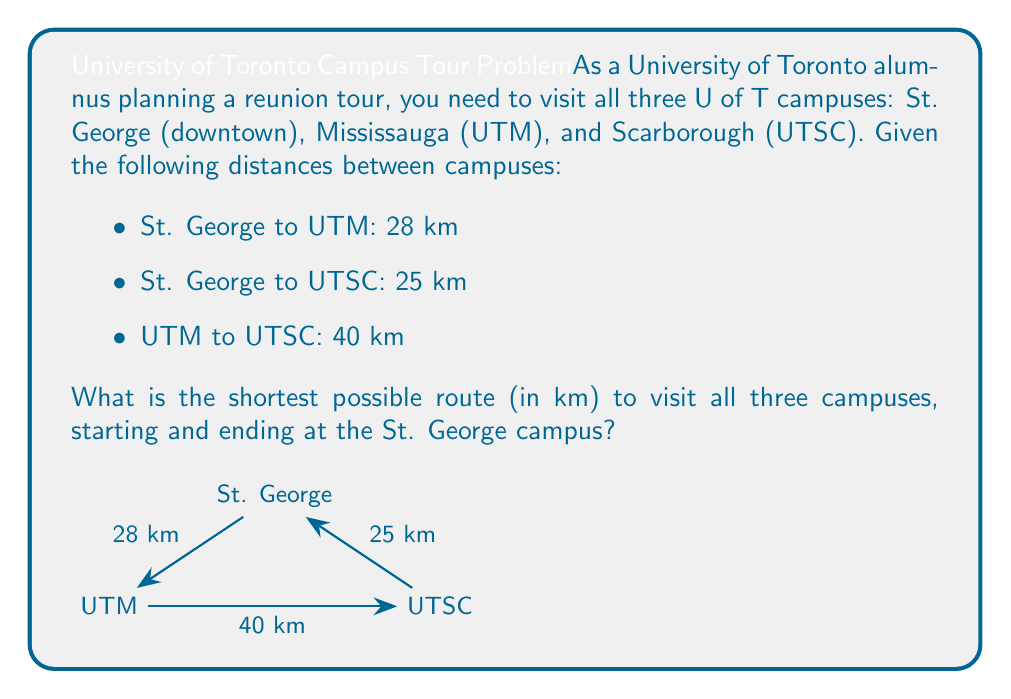Provide a solution to this math problem. To solve this problem, we need to consider all possible routes and compare their total distances:

1. St. George → UTM → UTSC → St. George
   Distance = $28 + 40 + 25 = 93$ km

2. St. George → UTSC → UTM → St. George
   Distance = $25 + 40 + 28 = 93$ km

Both routes have the same total distance of 93 km, which is the shortest possible route.

The reason this is the most efficient route is that it forms a triangle, visiting each campus exactly once before returning to the starting point. Any other route would involve backtracking, which would increase the total distance.

To prove this is optimal, we can consider the alternative:
3. St. George → UTM → St. George → UTSC → St. George
   Distance = $28 + 28 + 25 + 25 = 106$ km

This route is longer because it involves returning to St. George before visiting the last campus.

Therefore, the most efficient route is either:
St. George → UTM → UTSC → St. George
or
St. George → UTSC → UTM → St. George

Both of these routes have a total distance of 93 km.
Answer: 93 km 